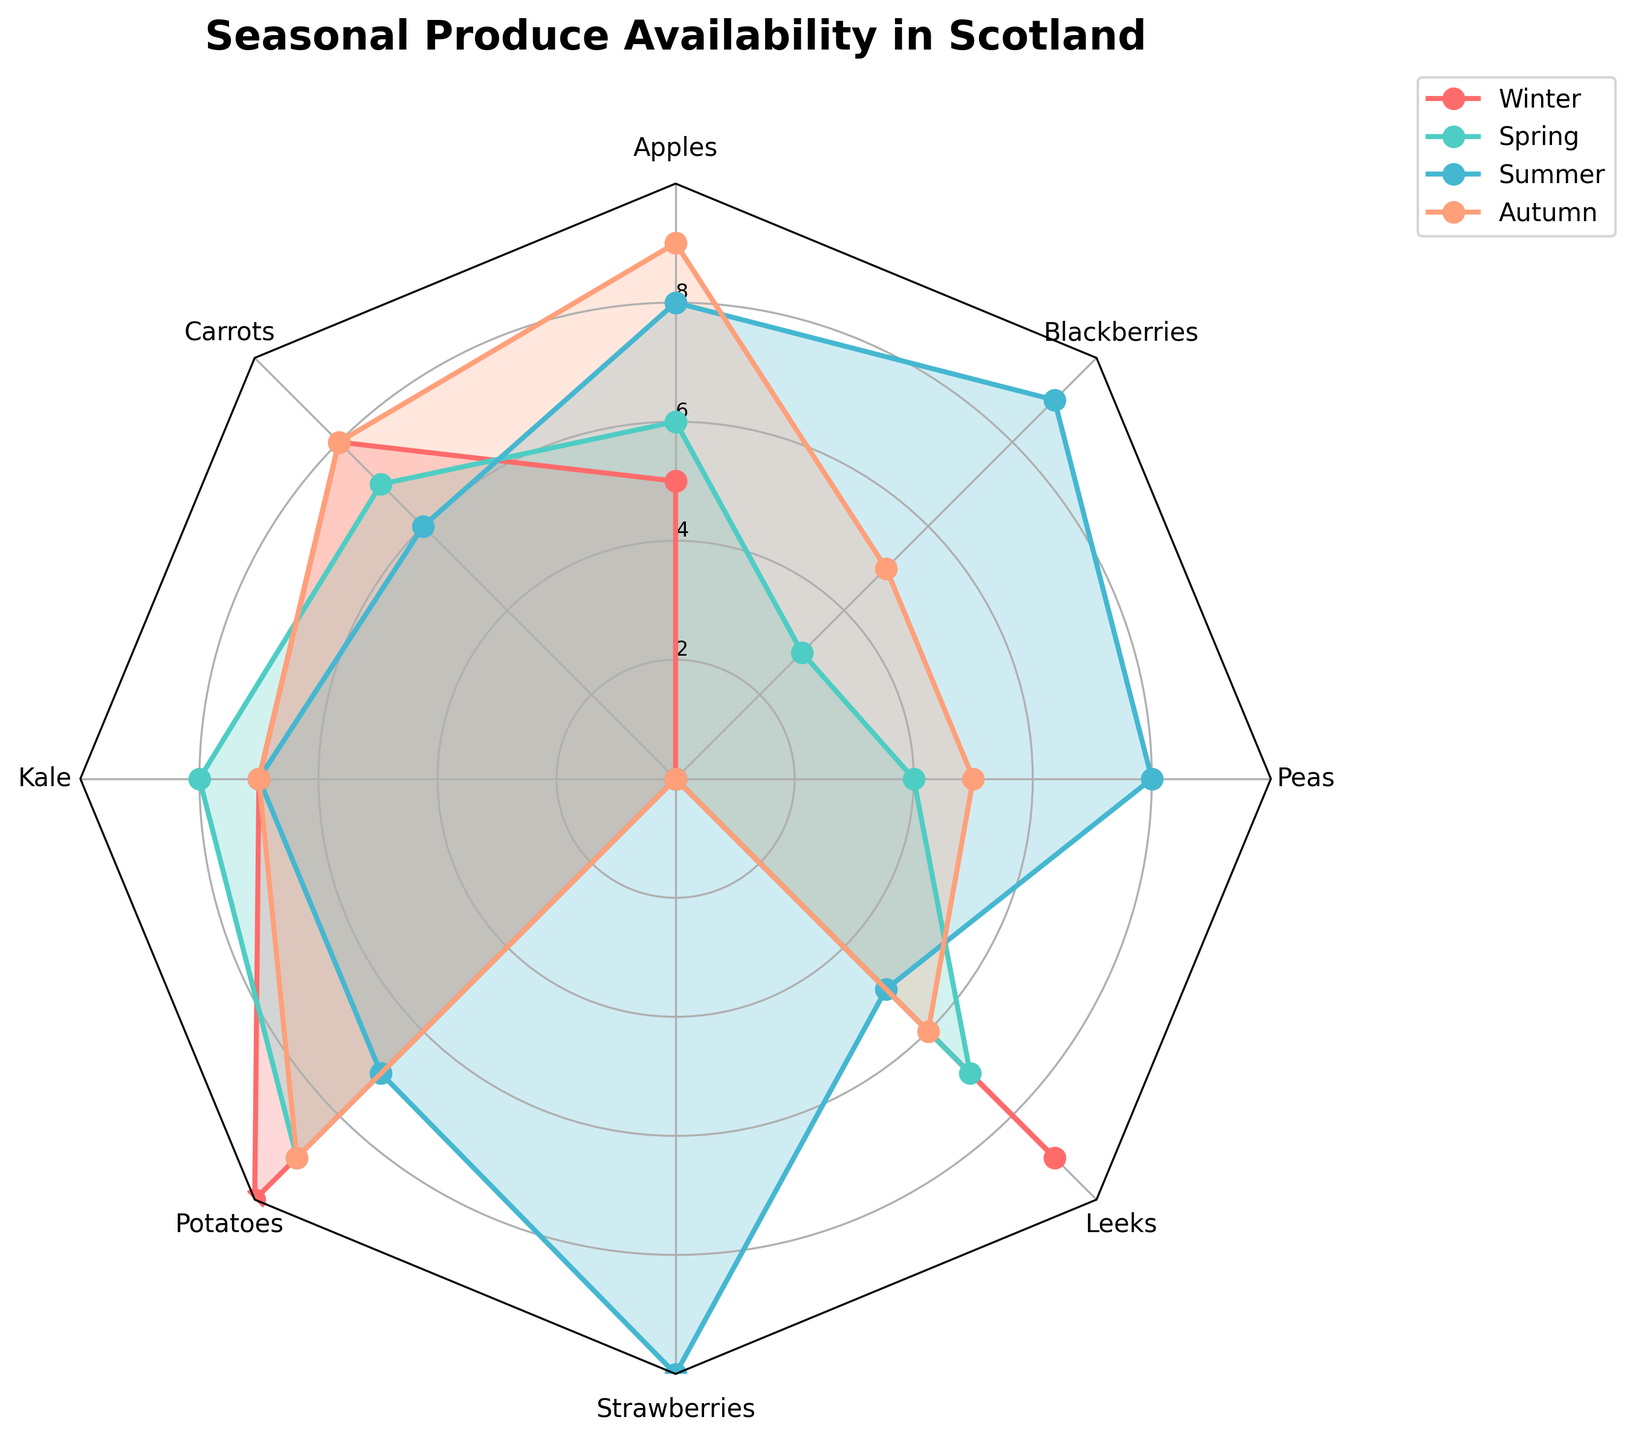what is the title of the radar chart? The title is located at the top of the radar chart and typically describes the overall content.
Answer: Seasonal Produce Availability in Scotland Which season has the highest apple availability? To find the highest apple availability, look for the season in which the apple point on the radar chart is farthest from the center.
Answer: Autumn In which season are strawberries available? Check the radial line for strawberries and identify the seasons where the plot marks are above zero.
Answer: Summer Among the given vegetables, which one has the highest availability in Winter? Look at the values plotted along the radial lines for each vegetable in the Winter season and identify the highest one.
Answer: Potatoes Which season records the lowest availability for leeks? On the radial line for leeks, identify the season with the plot mark closest to the center.
Answer: Summer How many types of produce are tracked in the radar chart? Count the radial lines extending from the center, each representing a different type of produce.
Answer: 8 What is the average availability of carrots across all seasons? Add up the carrot availability values for all seasons (8 + 7 + 6 + 8) and divide by the number of seasons (4).
Answer: 7.25 During which season is the availability of peas equal to the availability of kale? Compare the radial points for peas and kale to find the season where their plots coincide.
Answer: Summer Which season has the most balanced availability across all types of produce? Look for the season whose radar plot appears more circular/equally distributed among all produce types.
Answer: Spring How many seasons show availability of blackberries? Check each season's radial line for blackberries and count the seasons with plot marks above zero.
Answer: 2 